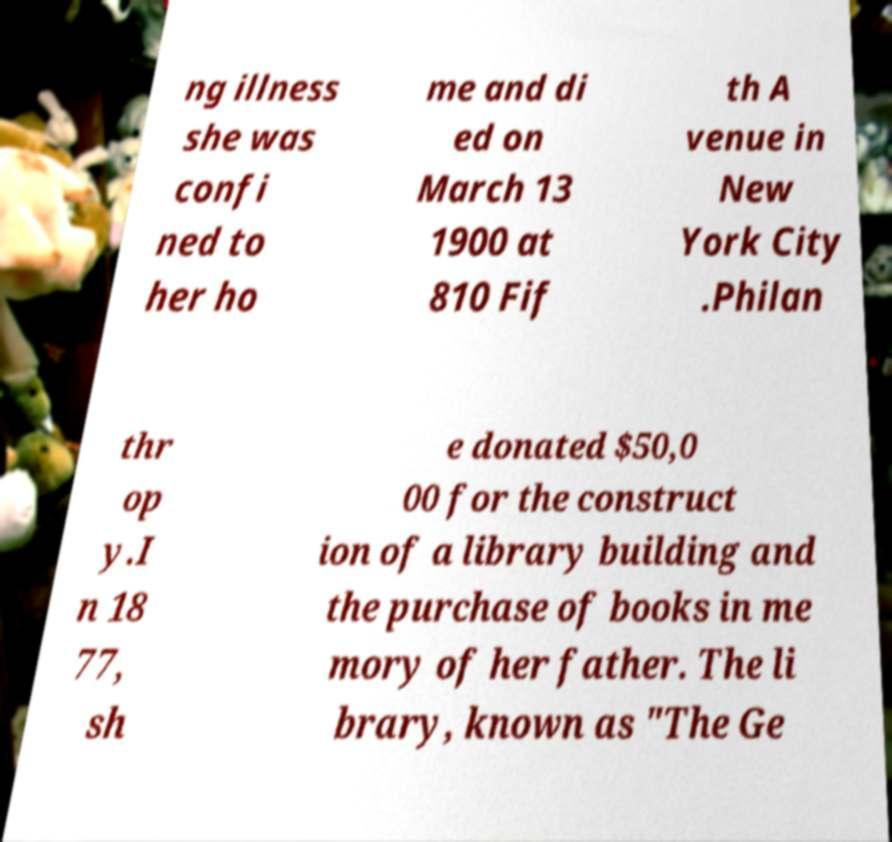What messages or text are displayed in this image? I need them in a readable, typed format. ng illness she was confi ned to her ho me and di ed on March 13 1900 at 810 Fif th A venue in New York City .Philan thr op y.I n 18 77, sh e donated $50,0 00 for the construct ion of a library building and the purchase of books in me mory of her father. The li brary, known as "The Ge 